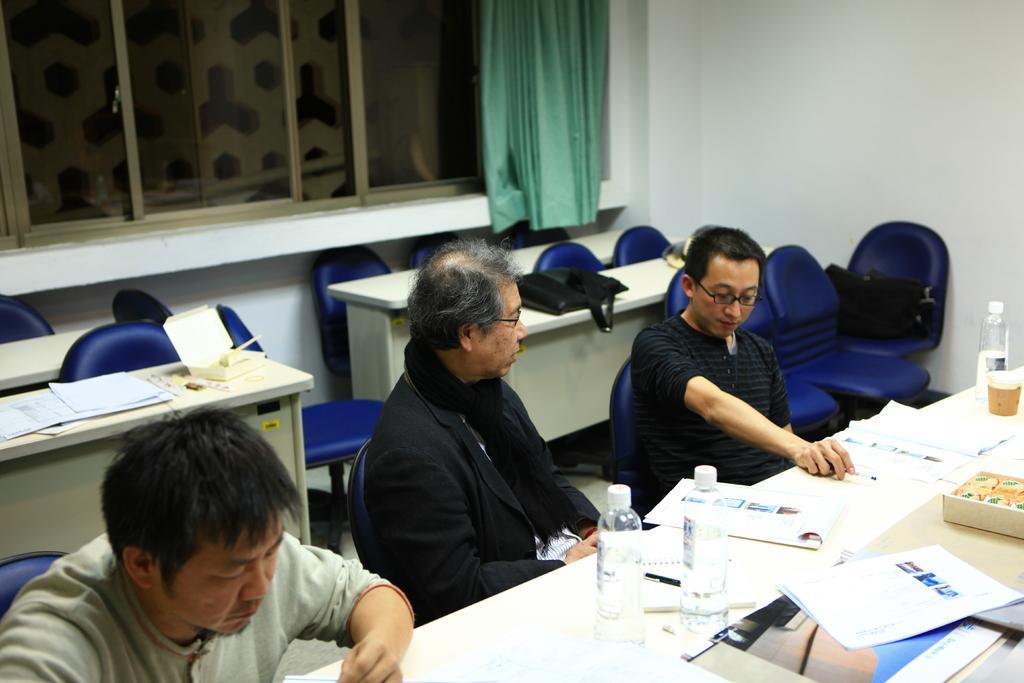Could you give a brief overview of what you see in this image? In this image I can see inside view of a room, in the room I can see tables, on the table there are bottles, papers, books, there are some chairs visible, on the cars there are three persons visible in front of table, there is a window, wall, a curtain. There is a black color bag kept on the table in the middle. 